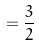Convert formula to latex. <formula><loc_0><loc_0><loc_500><loc_500>= \frac { 3 } { 2 }</formula> 